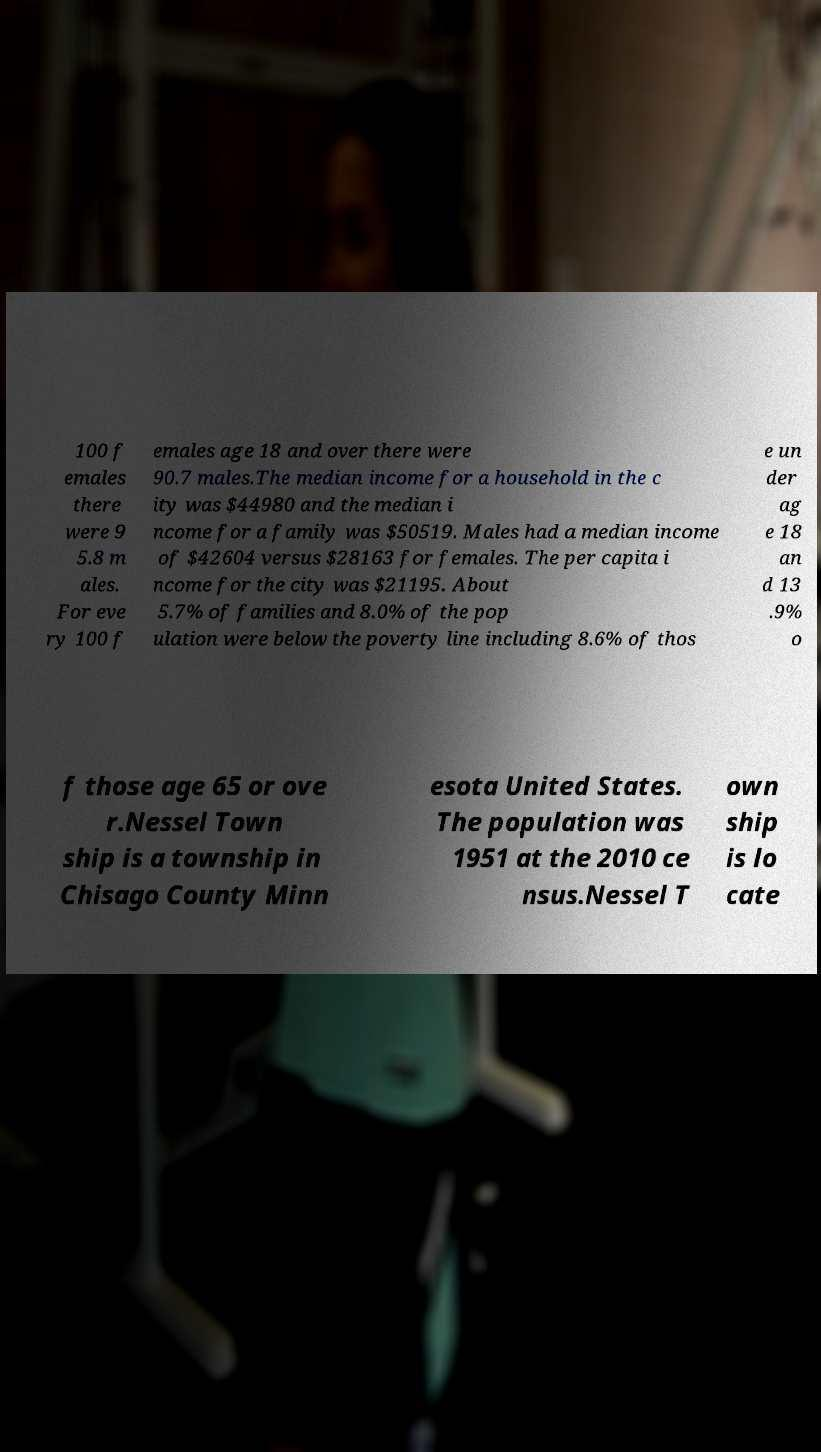Can you read and provide the text displayed in the image?This photo seems to have some interesting text. Can you extract and type it out for me? 100 f emales there were 9 5.8 m ales. For eve ry 100 f emales age 18 and over there were 90.7 males.The median income for a household in the c ity was $44980 and the median i ncome for a family was $50519. Males had a median income of $42604 versus $28163 for females. The per capita i ncome for the city was $21195. About 5.7% of families and 8.0% of the pop ulation were below the poverty line including 8.6% of thos e un der ag e 18 an d 13 .9% o f those age 65 or ove r.Nessel Town ship is a township in Chisago County Minn esota United States. The population was 1951 at the 2010 ce nsus.Nessel T own ship is lo cate 